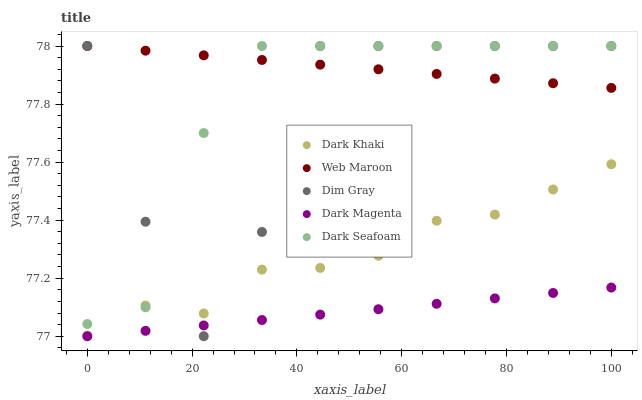Does Dark Magenta have the minimum area under the curve?
Answer yes or no. Yes. Does Web Maroon have the maximum area under the curve?
Answer yes or no. Yes. Does Dark Seafoam have the minimum area under the curve?
Answer yes or no. No. Does Dark Seafoam have the maximum area under the curve?
Answer yes or no. No. Is Dark Magenta the smoothest?
Answer yes or no. Yes. Is Dim Gray the roughest?
Answer yes or no. Yes. Is Dark Seafoam the smoothest?
Answer yes or no. No. Is Dark Seafoam the roughest?
Answer yes or no. No. Does Dark Magenta have the lowest value?
Answer yes or no. Yes. Does Dark Seafoam have the lowest value?
Answer yes or no. No. Does Web Maroon have the highest value?
Answer yes or no. Yes. Does Dark Magenta have the highest value?
Answer yes or no. No. Is Dark Magenta less than Web Maroon?
Answer yes or no. Yes. Is Dark Khaki greater than Dark Magenta?
Answer yes or no. Yes. Does Dark Magenta intersect Dim Gray?
Answer yes or no. Yes. Is Dark Magenta less than Dim Gray?
Answer yes or no. No. Is Dark Magenta greater than Dim Gray?
Answer yes or no. No. Does Dark Magenta intersect Web Maroon?
Answer yes or no. No. 